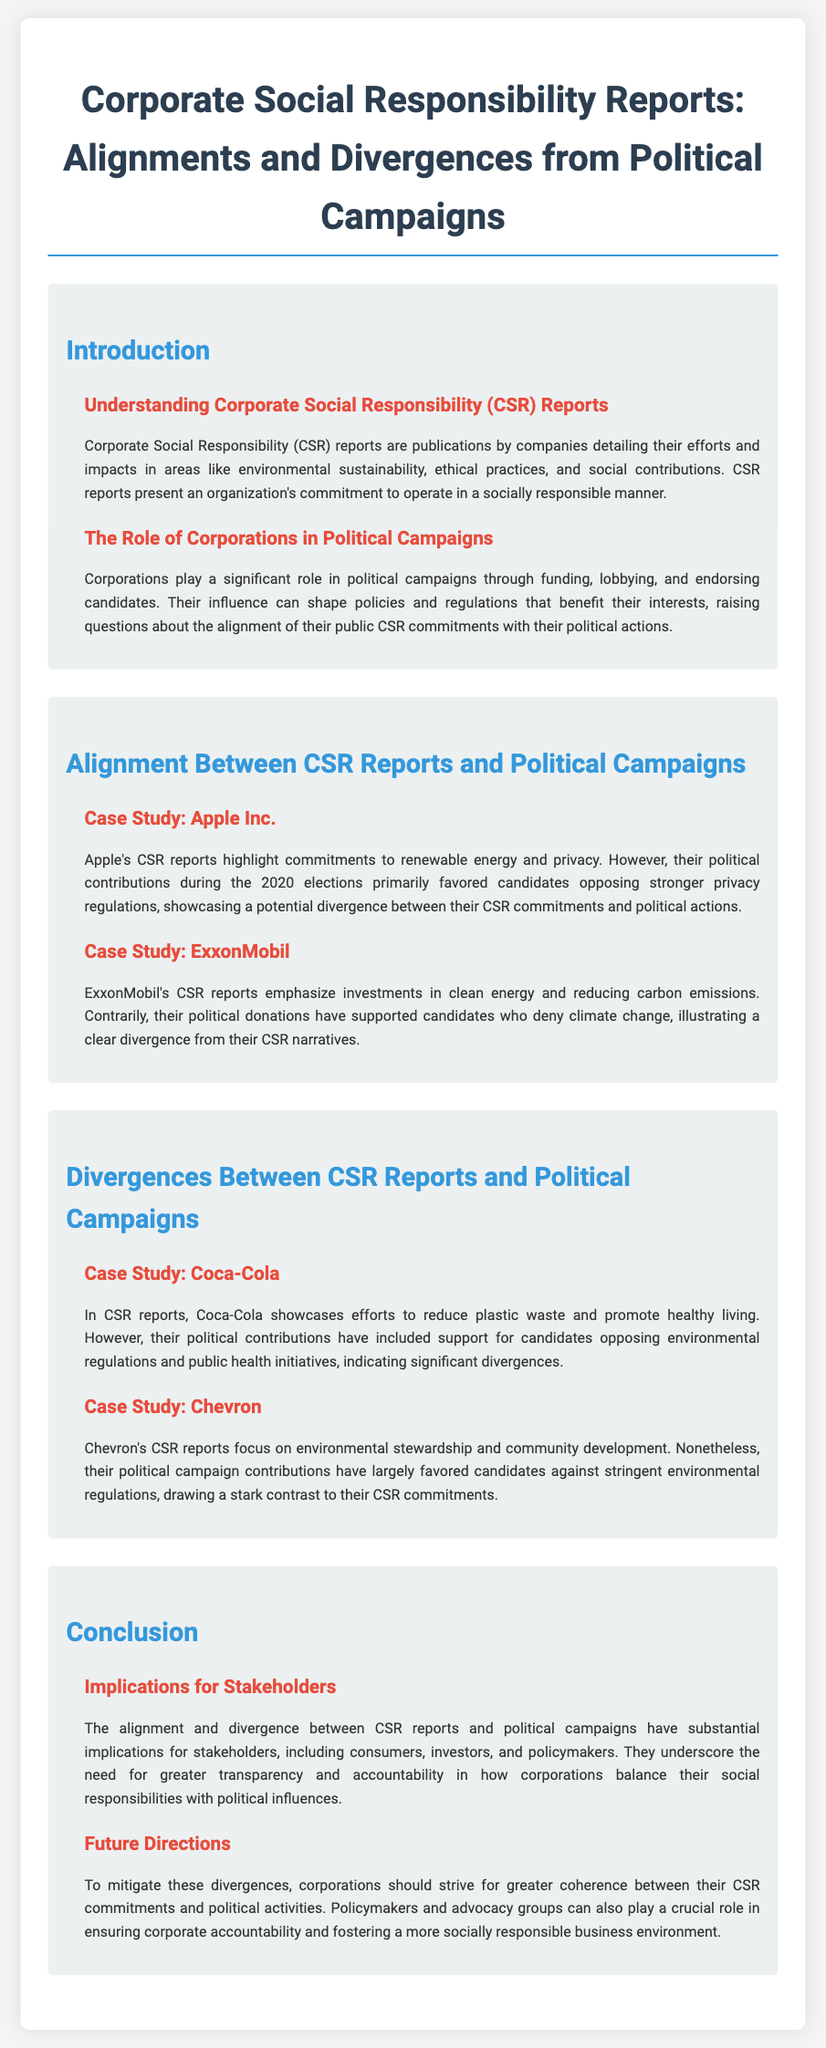What do CSR reports detail? CSR reports detail a company's efforts and impacts in areas like environmental sustainability, ethical practices, and social contributions.
Answer: Efforts and impacts in areas like environmental sustainability, ethical practices, and social contributions What role do corporations play in political campaigns? Corporations play a significant role in political campaigns through funding, lobbying, and endorsing candidates.
Answer: Funding, lobbying, and endorsing candidates Which company is highlighted in the case study for alignment? Apple Inc. is discussed in the case study regarding alignment between their CSR reports and political contributions.
Answer: Apple Inc What does ExxonMobil emphasize in their CSR reports? ExxonMobil emphasizes investments in clean energy and reducing carbon emissions in their CSR reports.
Answer: Investments in clean energy and reducing carbon emissions Which company shows significant divergences in political contributions? Coca-Cola shows significant divergences in political contributions compared to their CSR commitments.
Answer: Coca-Cola What is the implication of alignment and divergence for stakeholders? The alignment and divergence have substantial implications for stakeholders, including consumers, investors, and policymakers.
Answer: Substantial implications for stakeholders What future direction is suggested for corporations? Corporations should strive for greater coherence between their CSR commitments and political activities.
Answer: Greater coherence between CSR commitments and political activities Which company opposed strong privacy regulations during the 2020 elections? Apple Inc. favored candidates opposing stronger privacy regulations during the 2020 elections.
Answer: Apple Inc What is Chevron's focus in their CSR reports? Chevron focuses on environmental stewardship and community development in their CSR reports.
Answer: Environmental stewardship and community development 